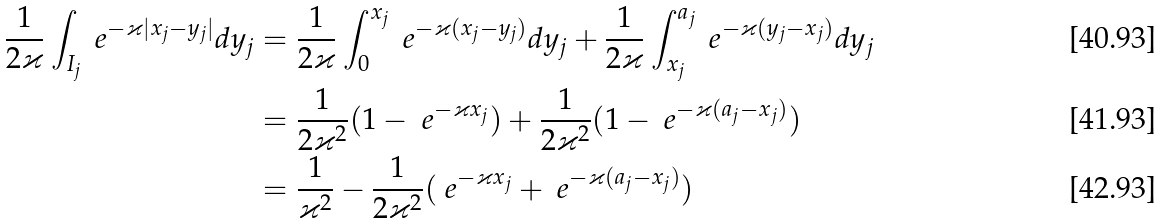Convert formula to latex. <formula><loc_0><loc_0><loc_500><loc_500>\frac { 1 } { 2 \varkappa } \int _ { I _ { j } } \ e ^ { - \varkappa | x _ { j } - y _ { j } | } d y _ { j } & = \frac { 1 } { 2 \varkappa } \int _ { 0 } ^ { x _ { j } } \ e ^ { - \varkappa ( x _ { j } - y _ { j } ) } d y _ { j } + \frac { 1 } { 2 \varkappa } \int _ { x _ { j } } ^ { a _ { j } } \ e ^ { - \varkappa ( y _ { j } - x _ { j } ) } d y _ { j } \\ & = \frac { 1 } { 2 \varkappa ^ { 2 } } ( 1 - \ e ^ { - \varkappa x _ { j } } ) + \frac { 1 } { 2 \varkappa ^ { 2 } } ( 1 - \ e ^ { - \varkappa ( a _ { j } - x _ { j } ) } ) \\ & = \frac { 1 } { \varkappa ^ { 2 } } - \frac { 1 } { 2 \varkappa ^ { 2 } } ( \ e ^ { - \varkappa x _ { j } } + \ e ^ { - \varkappa ( a _ { j } - x _ { j } ) } )</formula> 